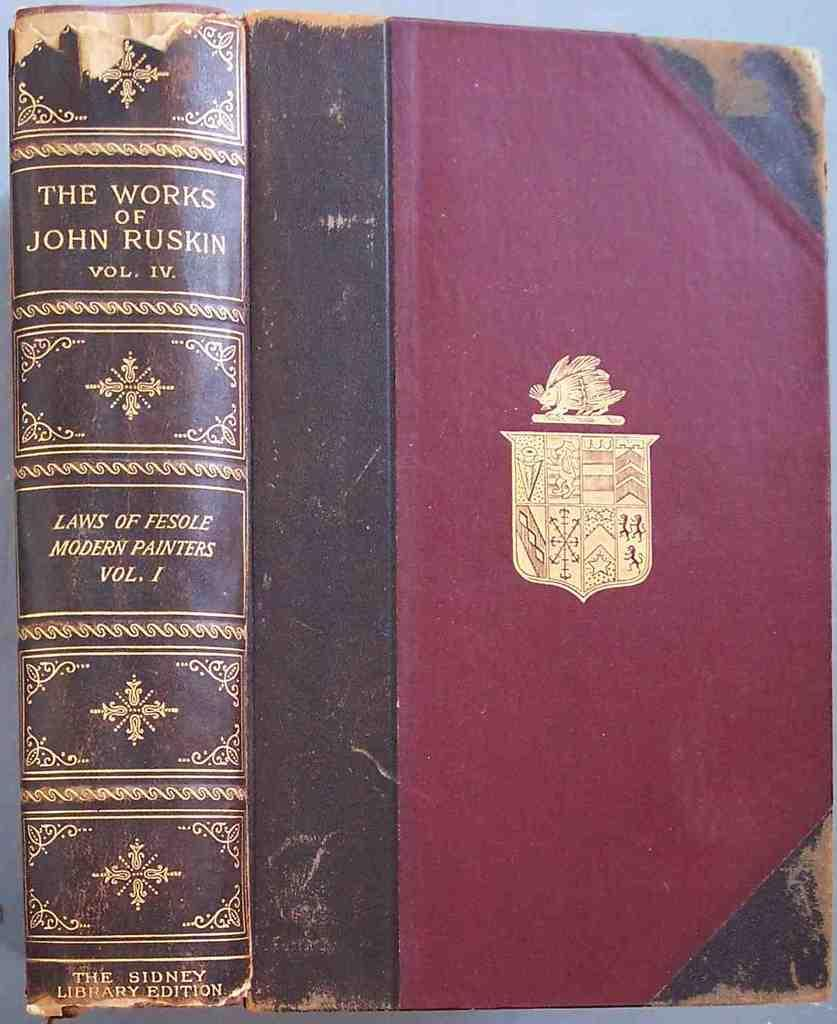Provide a one-sentence caption for the provided image. An old leather bound book called "The Works of John Ruskin Volume IV". 